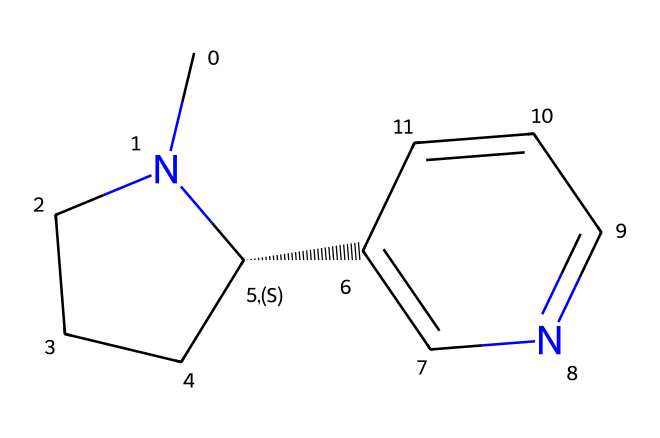What is the molecular formula of this compound? First, count the number of each type of atom in the SMILES representation. There are 10 carbon (C) atoms, 14 hydrogen (H) atoms, and 2 nitrogen (N) atoms. Therefore, the molecular formula is C10H14N2.
Answer: C10H14N2 How many nitrogen atoms are present in this chemical structure? By analyzing the SMILES representation, there are 2 instances of the nitrogen (N) atom. Thus, there are 2 nitrogen atoms in total.
Answer: 2 What type of chemical is nicotine classified as? Nicotine is classified as an alkaloid based on its nitrogen-containing structure and its basic properties, typical of compounds derived from plants that have a pronounced physiological effect.
Answer: alkaloid Does this chemical contain any double bonds? Examining the structure in the SMILES, there is a presence of double bonds, particularly between the carbon atoms and also between carbon and nitrogen. Therefore, yes, it contains double bonds.
Answer: yes What is the stereochemistry indicated in the structure of nicotine? The notation [C@H] in the SMILES indicates that there is a chiral center in the molecule. This means that the carbon atom attached to the nitrogen has a specific spatial arrangement, which is crucial for its biological activity.
Answer: chiral What functional groups are present in this molecule? In analyzing the SMILES, the presence of the nitrogen atoms suggests that the molecule contains amine functional groups as it has basic nitrogen atoms, characteristic of alkaloids.
Answer: amine 